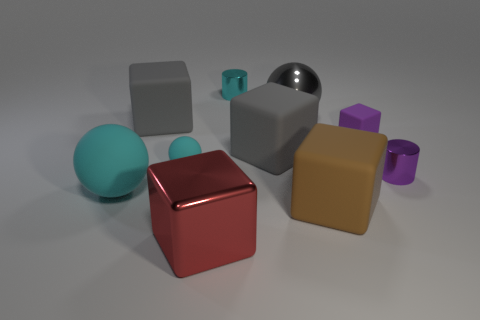Do the small thing on the left side of the red cube and the purple cylinder have the same material?
Your answer should be compact. No. What is the size of the cylinder behind the metallic thing that is right of the brown cube?
Your answer should be compact. Small. The sphere that is in front of the purple cube and on the right side of the big cyan matte object is what color?
Ensure brevity in your answer.  Cyan. There is a cyan sphere that is the same size as the metal cube; what is it made of?
Offer a terse response. Rubber. How many other objects are there of the same material as the brown object?
Ensure brevity in your answer.  5. Do the small metallic thing on the left side of the big brown rubber cube and the matte object that is behind the small purple block have the same color?
Provide a short and direct response. No. There is a small shiny thing on the left side of the large gray cube in front of the purple rubber cube; what is its shape?
Make the answer very short. Cylinder. What number of other objects are there of the same color as the small ball?
Provide a short and direct response. 2. Are the large red cube to the right of the large cyan rubber thing and the sphere that is right of the big red object made of the same material?
Offer a very short reply. Yes. What size is the brown thing right of the tiny cyan rubber sphere?
Offer a very short reply. Large. 